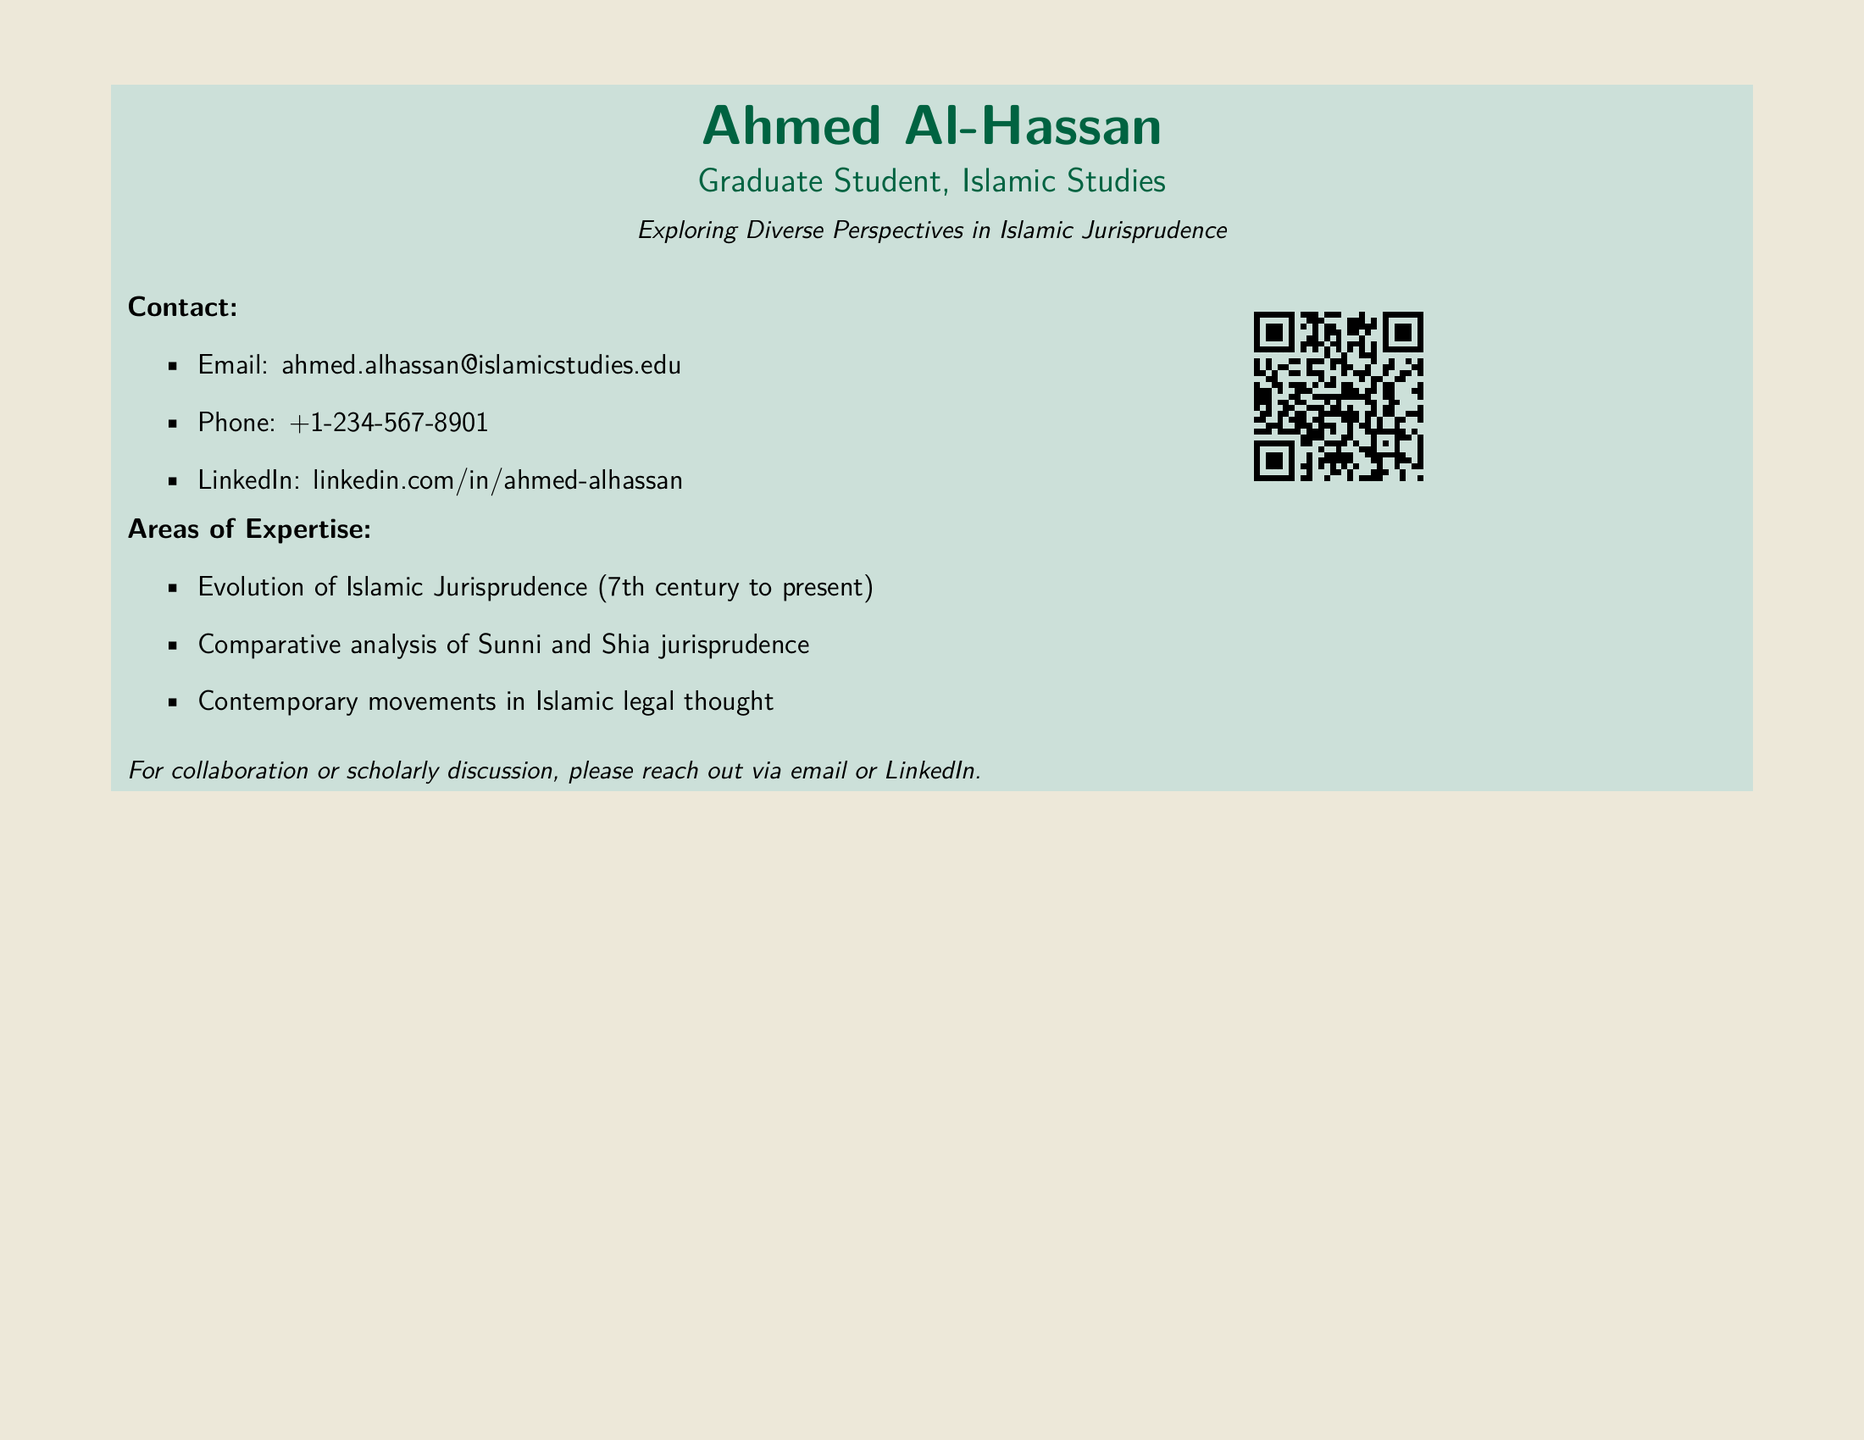What is the name of the graduate student? The document presents the name of the graduate student at the top, which is "Ahmed Al-Hassan."
Answer: Ahmed Al-Hassan What is the email address listed? The email address for contact is provided in the document: "ahmed.alhassan@islamicstudies.edu."
Answer: ahmed.alhassan@islamicstudies.edu What area of expertise covers the period from the 7th century? The document lists "Evolution of Islamic Jurisprudence (7th century to present)" as an area of expertise.
Answer: Evolution of Islamic Jurisprudence (7th century to present) What is the phone number provided? The phone number for contact is included in the document, which is "+1-234-567-8901."
Answer: +1-234-567-8901 How many areas of expertise are listed? The document provides a total of three areas of expertise.
Answer: 3 What social media platform is mentioned in the document? The document references "LinkedIn" as the social media platform for professional networking.
Answer: LinkedIn What is the purpose of including a QR code? The QR code allows for quick access to the LinkedIn profile mentioned, enhancing connectivity.
Answer: Quick access to LinkedIn profile What can be inferred about his scholarly focus? The document suggests a strong emphasis on exploring diverse perspectives within Islamic jurisprudence.
Answer: Exploring diverse perspectives in Islamic jurisprudence What is the document's layout type? The document is structured as a business card, which typically contains personal and professional information.
Answer: Business card 